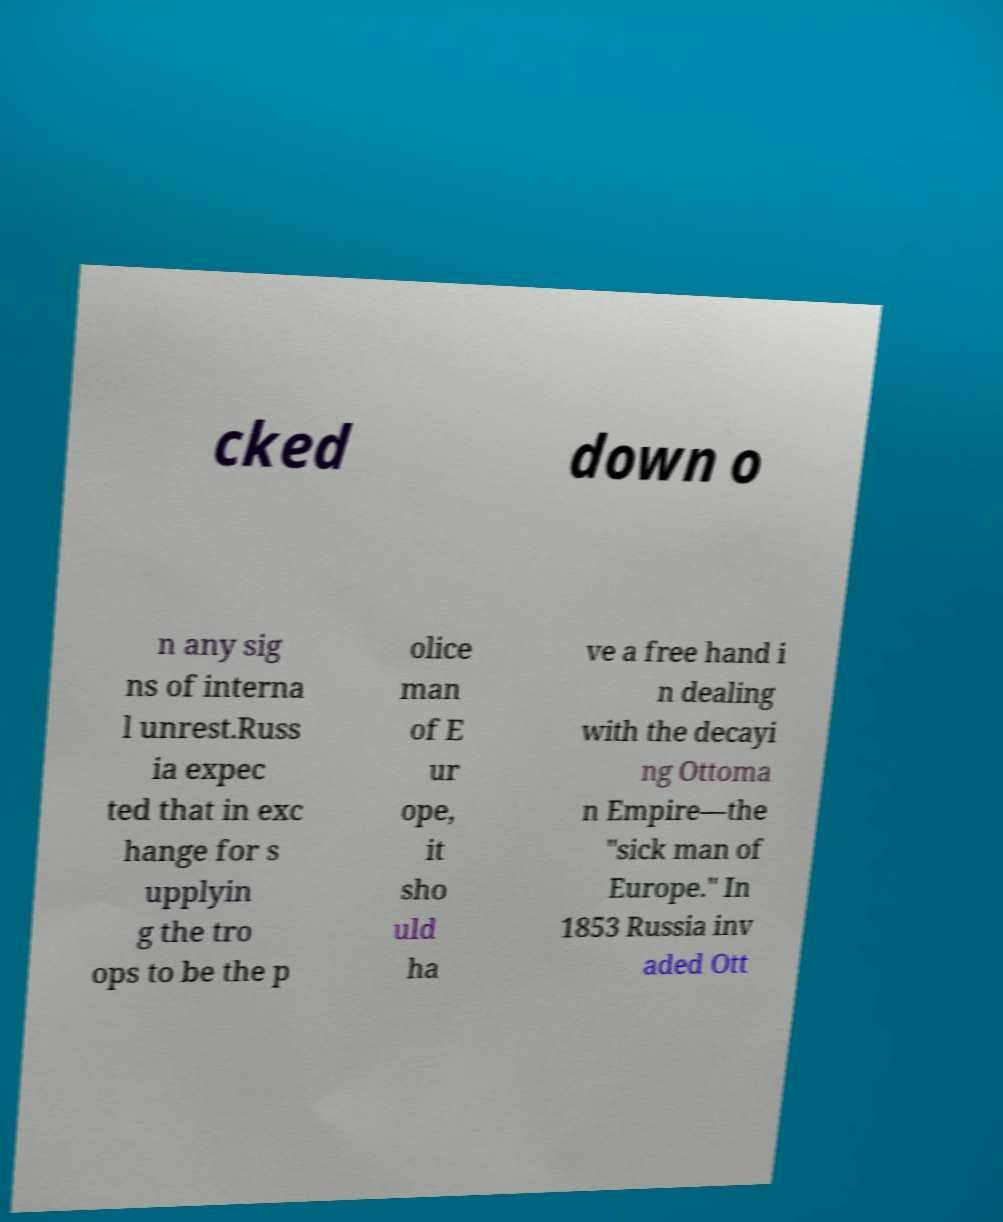What messages or text are displayed in this image? I need them in a readable, typed format. cked down o n any sig ns of interna l unrest.Russ ia expec ted that in exc hange for s upplyin g the tro ops to be the p olice man of E ur ope, it sho uld ha ve a free hand i n dealing with the decayi ng Ottoma n Empire—the "sick man of Europe." In 1853 Russia inv aded Ott 